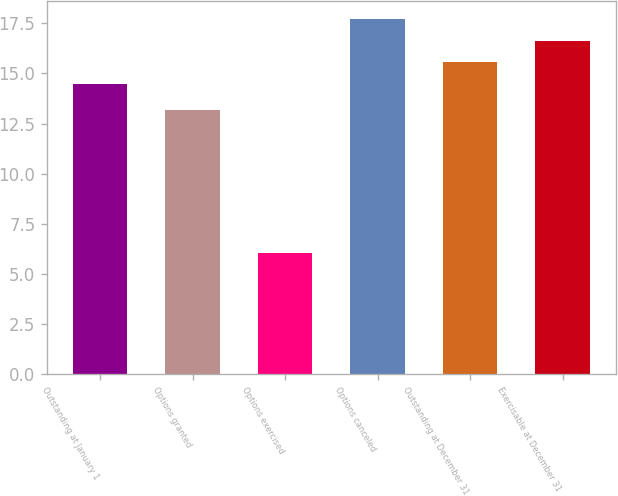Convert chart. <chart><loc_0><loc_0><loc_500><loc_500><bar_chart><fcel>Outstanding at January 1<fcel>Options granted<fcel>Options exercised<fcel>Options canceled<fcel>Outstanding at December 31<fcel>Exercisable at December 31<nl><fcel>14.48<fcel>13.17<fcel>6.04<fcel>17.72<fcel>15.56<fcel>16.64<nl></chart> 